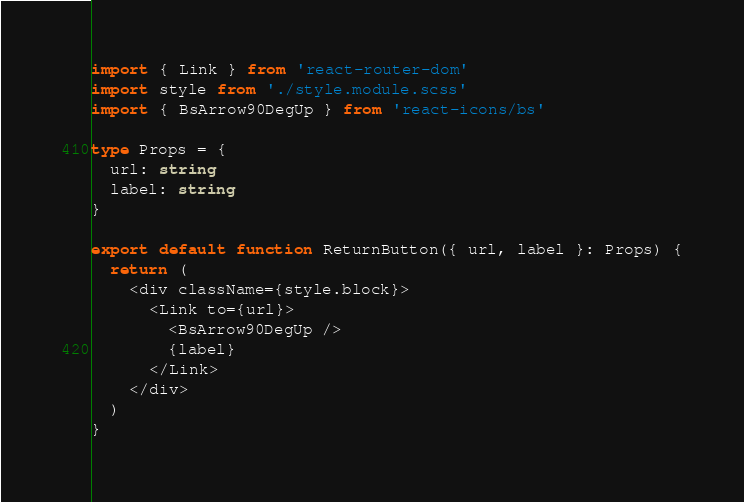<code> <loc_0><loc_0><loc_500><loc_500><_TypeScript_>import { Link } from 'react-router-dom'
import style from './style.module.scss'
import { BsArrow90DegUp } from 'react-icons/bs'

type Props = {
  url: string
  label: string
}

export default function ReturnButton({ url, label }: Props) {
  return (
    <div className={style.block}>
      <Link to={url}>
        <BsArrow90DegUp />
        {label}
      </Link>
    </div>
  )
}
</code> 